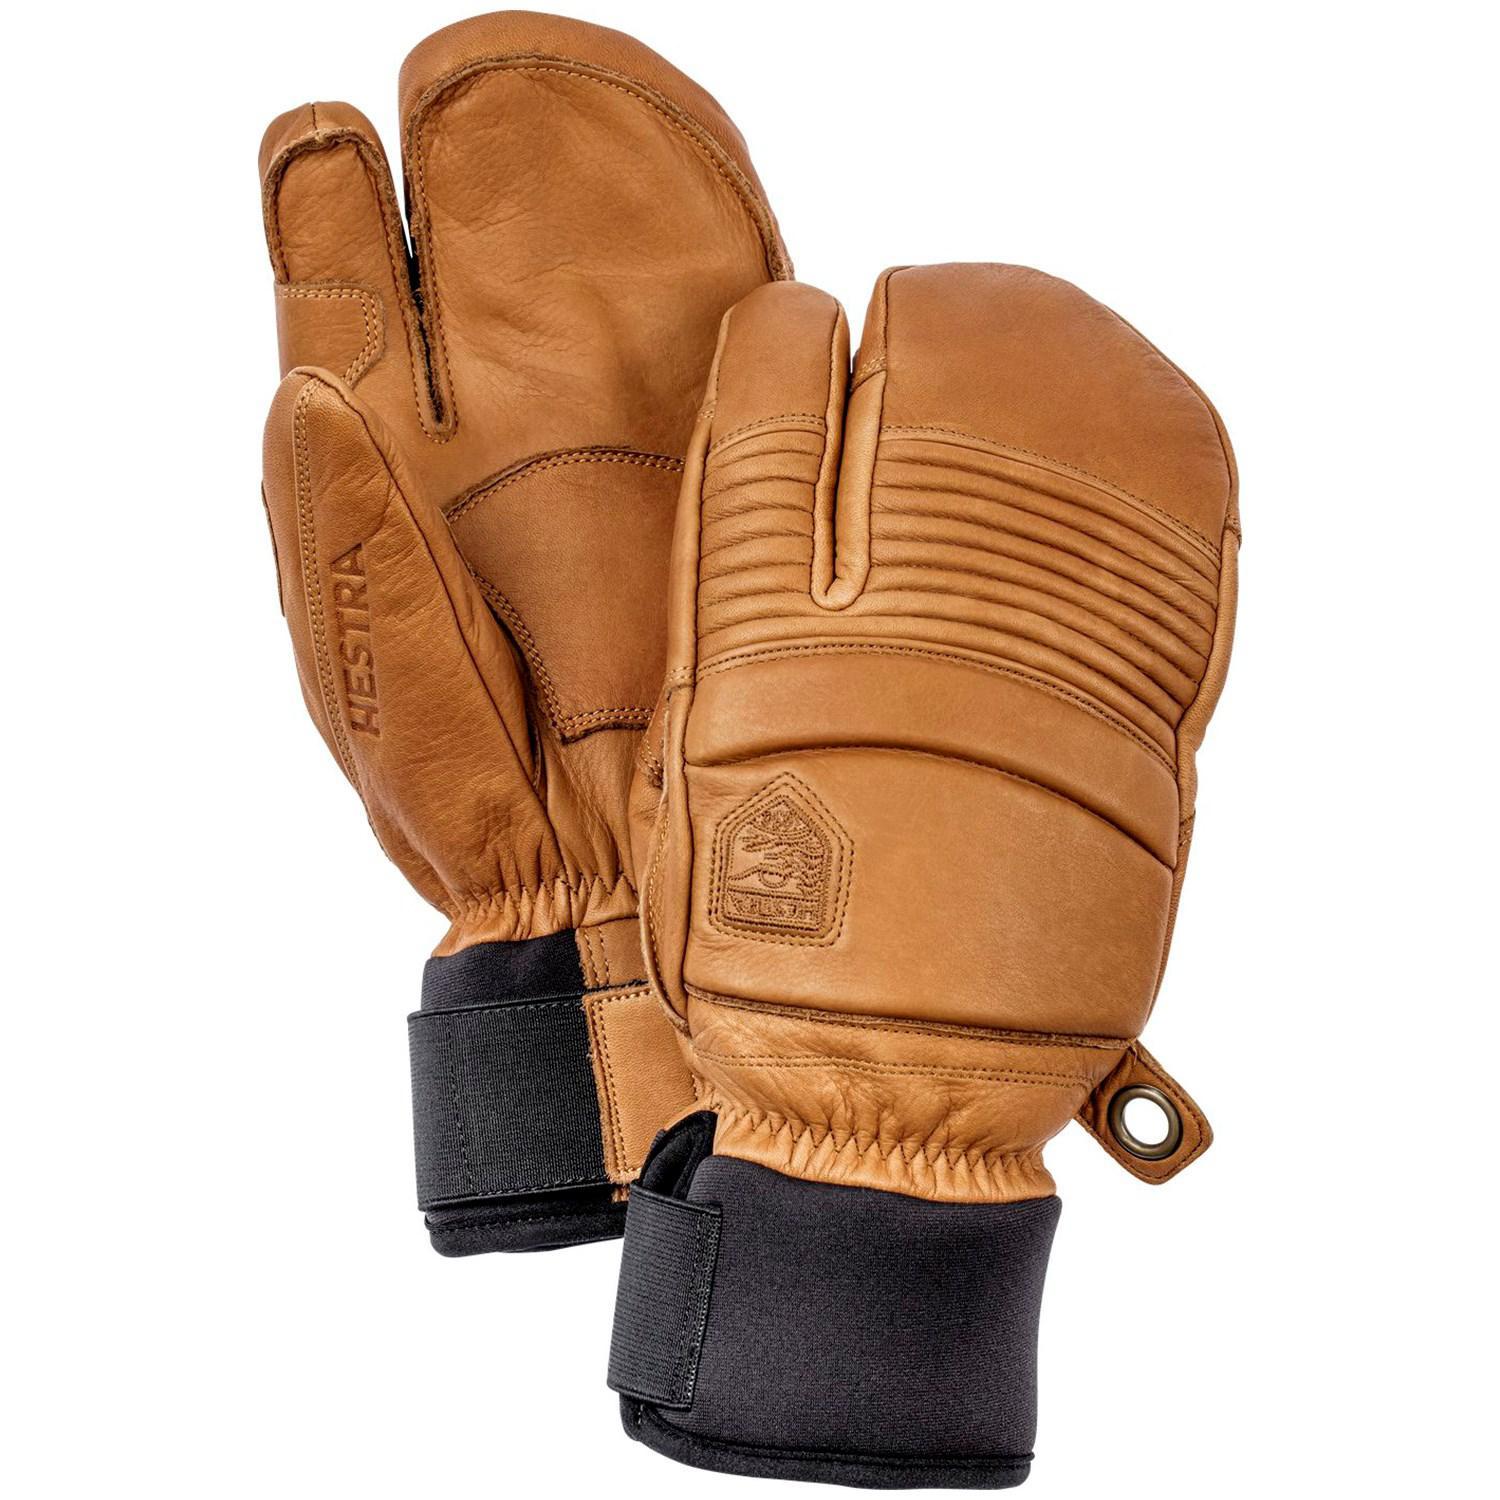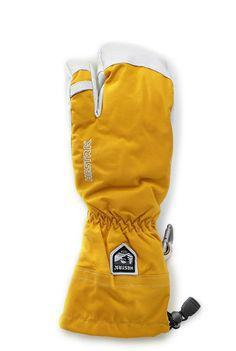The first image is the image on the left, the second image is the image on the right. Examine the images to the left and right. Is the description "Both images show the front and back side of a pair of gloves." accurate? Answer yes or no. No. 